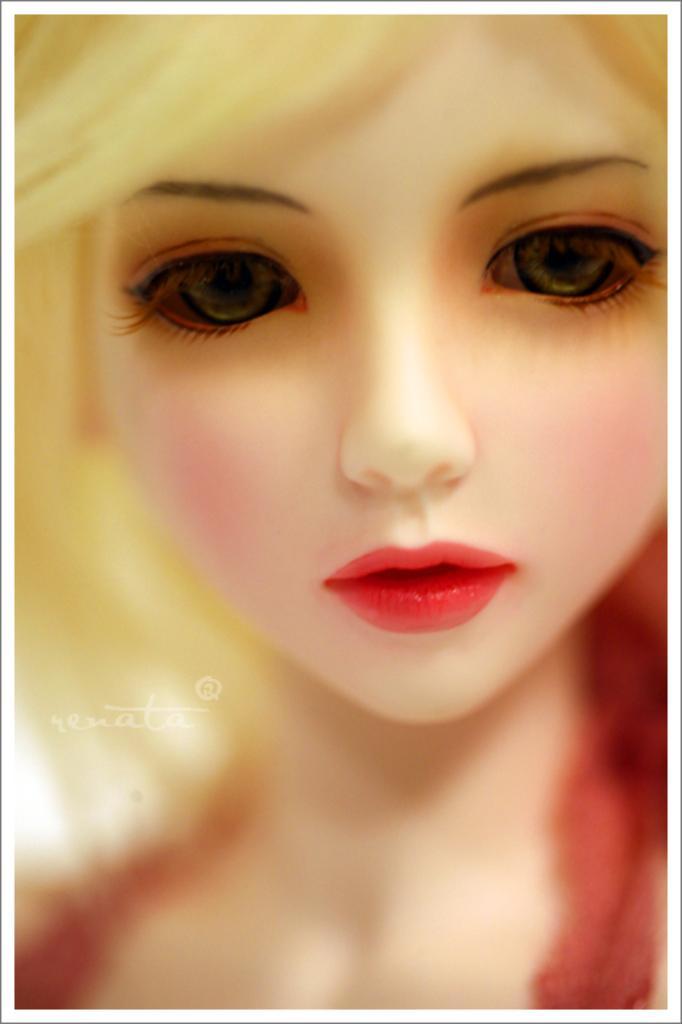Could you give a brief overview of what you see in this image? Here we can see a person face. Left side of the image there is a watermark. 